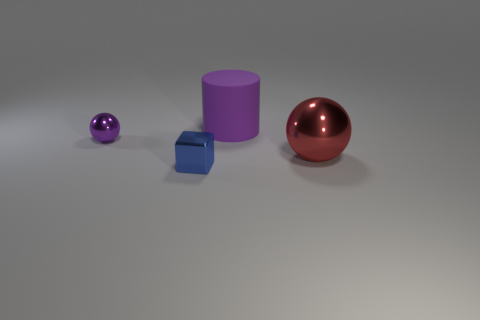There is a tiny metal object in front of the large sphere; is its color the same as the big object that is behind the large red metallic thing?
Provide a short and direct response. No. How many things are both left of the blue object and on the right side of the blue cube?
Your answer should be compact. 0. There is a purple sphere that is the same material as the tiny block; what size is it?
Offer a very short reply. Small. What is the size of the cylinder?
Your answer should be compact. Large. What is the blue block made of?
Provide a short and direct response. Metal. Do the sphere that is left of the red sphere and the tiny blue shiny object have the same size?
Your answer should be very brief. Yes. How many objects are either tiny balls or yellow blocks?
Your answer should be compact. 1. There is a small shiny thing that is the same color as the matte thing; what is its shape?
Offer a very short reply. Sphere. What size is the object that is behind the tiny cube and to the left of the big rubber cylinder?
Keep it short and to the point. Small. Is the number of yellow rubber cubes the same as the number of shiny things?
Offer a terse response. No. 